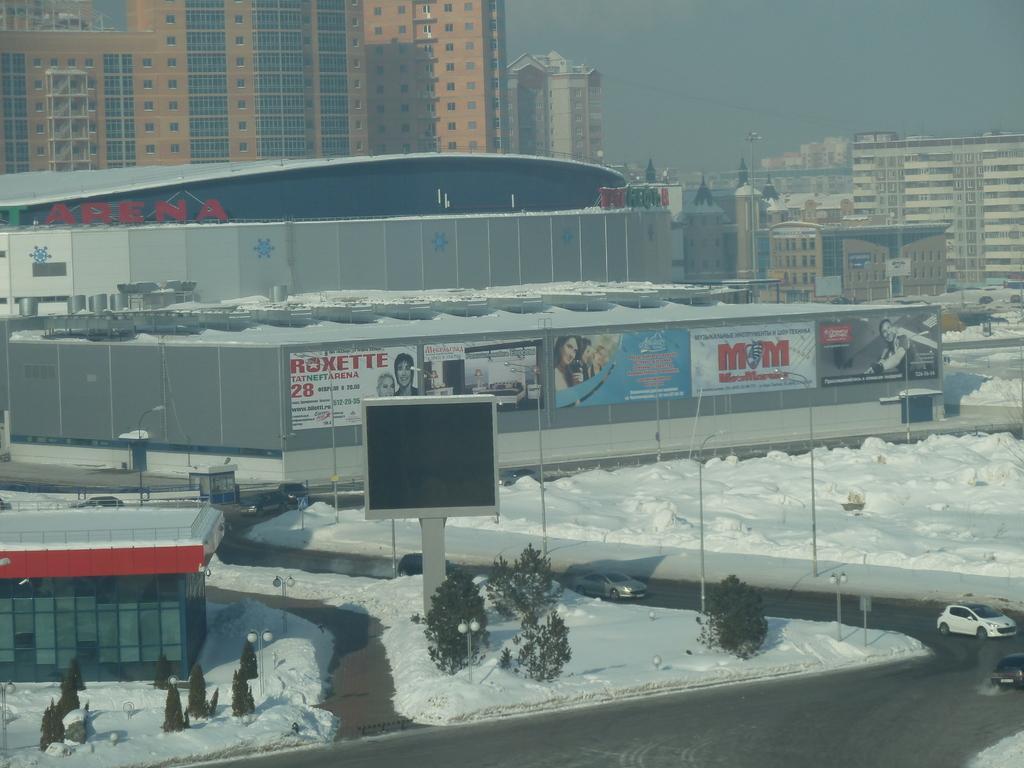Describe this image in one or two sentences. In this image I can see buildings , the sky in the middle , in front of them I can see snow visible on the floor , on the floor I can see plants and poles and I can see a road visible at the bottom , on the road I can see vehicles visible 